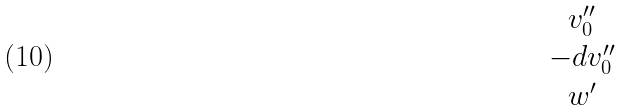Convert formula to latex. <formula><loc_0><loc_0><loc_500><loc_500>\begin{matrix} v ^ { \prime \prime } _ { 0 } \\ - d v ^ { \prime \prime } _ { 0 } \\ w ^ { \prime } \end{matrix}</formula> 